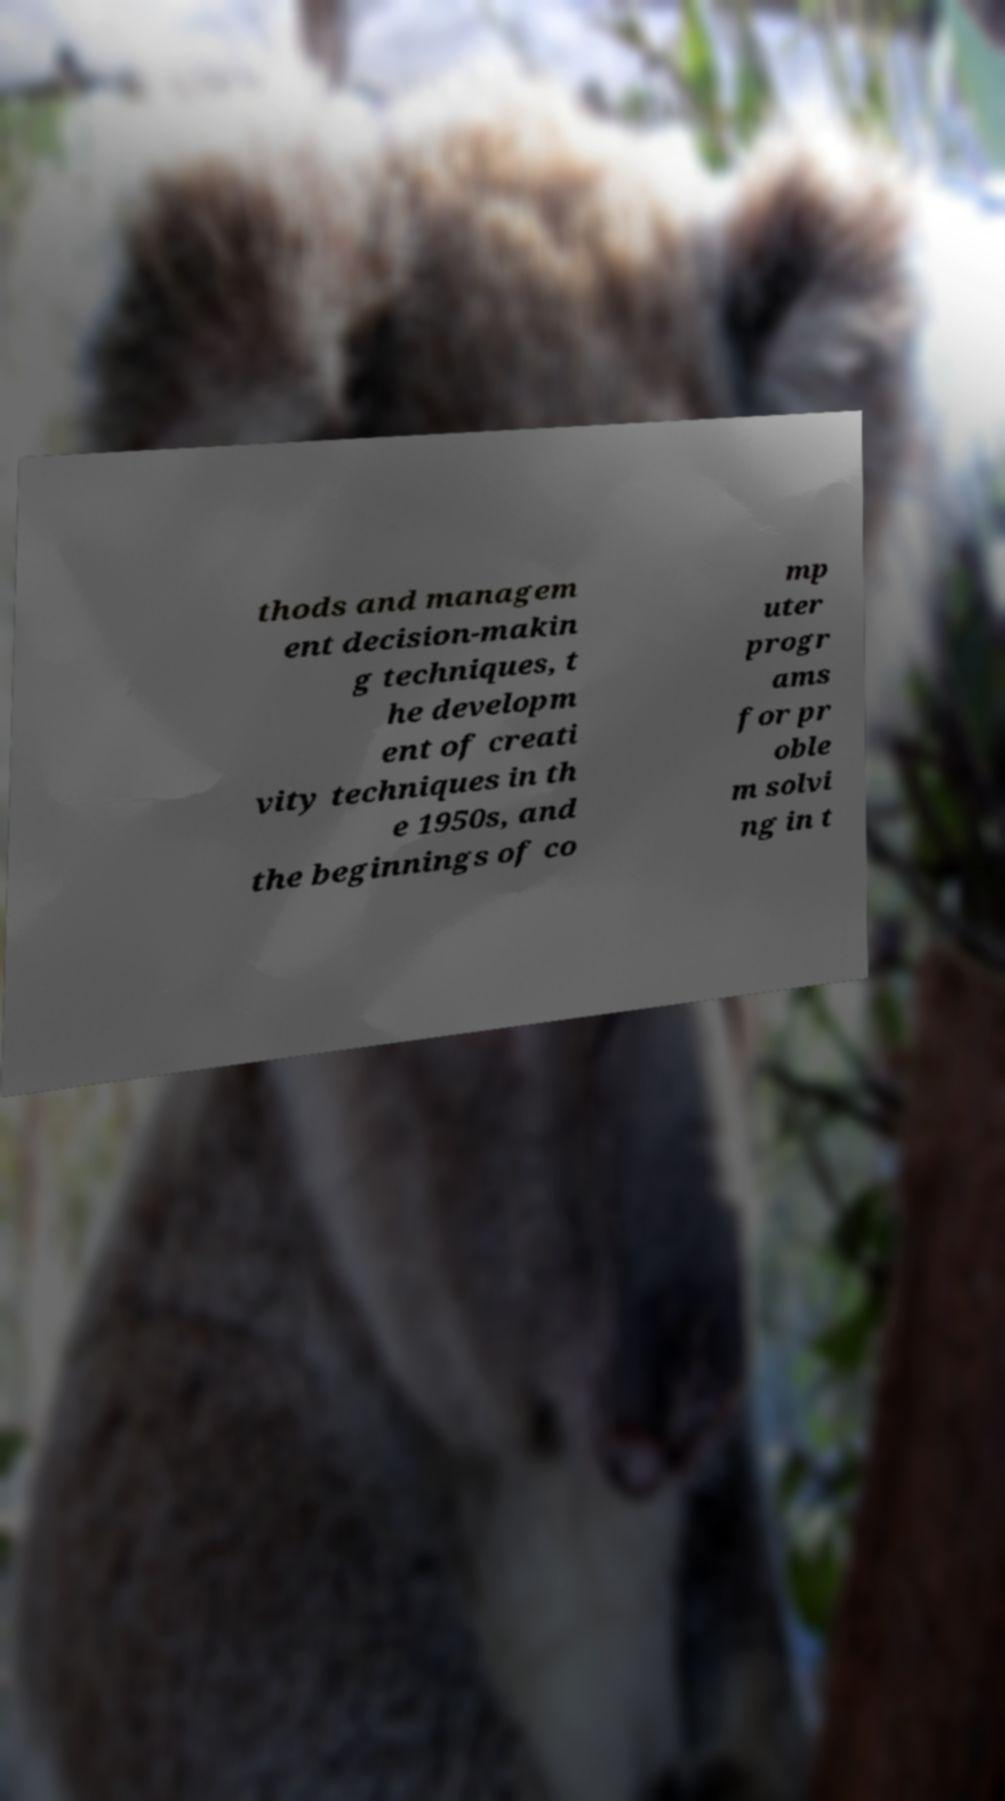Can you read and provide the text displayed in the image?This photo seems to have some interesting text. Can you extract and type it out for me? thods and managem ent decision-makin g techniques, t he developm ent of creati vity techniques in th e 1950s, and the beginnings of co mp uter progr ams for pr oble m solvi ng in t 